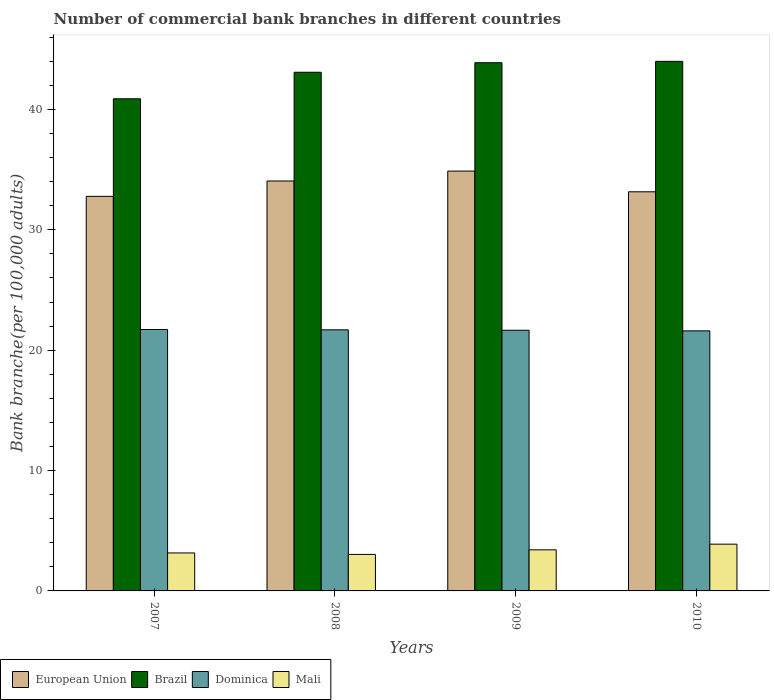How many different coloured bars are there?
Give a very brief answer. 4. How many groups of bars are there?
Give a very brief answer. 4. Are the number of bars per tick equal to the number of legend labels?
Provide a succinct answer. Yes. Are the number of bars on each tick of the X-axis equal?
Make the answer very short. Yes. How many bars are there on the 2nd tick from the right?
Make the answer very short. 4. What is the label of the 2nd group of bars from the left?
Provide a short and direct response. 2008. In how many cases, is the number of bars for a given year not equal to the number of legend labels?
Offer a very short reply. 0. What is the number of commercial bank branches in Brazil in 2008?
Your answer should be very brief. 43.09. Across all years, what is the maximum number of commercial bank branches in Brazil?
Keep it short and to the point. 43.99. Across all years, what is the minimum number of commercial bank branches in European Union?
Keep it short and to the point. 32.78. In which year was the number of commercial bank branches in Brazil minimum?
Make the answer very short. 2007. What is the total number of commercial bank branches in Dominica in the graph?
Offer a very short reply. 86.67. What is the difference between the number of commercial bank branches in Brazil in 2008 and that in 2009?
Your answer should be compact. -0.79. What is the difference between the number of commercial bank branches in Brazil in 2007 and the number of commercial bank branches in Mali in 2010?
Offer a terse response. 37. What is the average number of commercial bank branches in Mali per year?
Your response must be concise. 3.37. In the year 2008, what is the difference between the number of commercial bank branches in Dominica and number of commercial bank branches in European Union?
Offer a very short reply. -12.36. What is the ratio of the number of commercial bank branches in European Union in 2008 to that in 2010?
Give a very brief answer. 1.03. What is the difference between the highest and the second highest number of commercial bank branches in Mali?
Keep it short and to the point. 0.47. What is the difference between the highest and the lowest number of commercial bank branches in Brazil?
Provide a succinct answer. 3.11. Is the sum of the number of commercial bank branches in Brazil in 2007 and 2010 greater than the maximum number of commercial bank branches in Dominica across all years?
Provide a short and direct response. Yes. What does the 2nd bar from the left in 2007 represents?
Give a very brief answer. Brazil. What does the 4th bar from the right in 2010 represents?
Keep it short and to the point. European Union. Are all the bars in the graph horizontal?
Give a very brief answer. No. What is the difference between two consecutive major ticks on the Y-axis?
Your answer should be very brief. 10. Are the values on the major ticks of Y-axis written in scientific E-notation?
Keep it short and to the point. No. Does the graph contain any zero values?
Ensure brevity in your answer.  No. Does the graph contain grids?
Your answer should be compact. No. Where does the legend appear in the graph?
Provide a succinct answer. Bottom left. What is the title of the graph?
Keep it short and to the point. Number of commercial bank branches in different countries. Does "Belarus" appear as one of the legend labels in the graph?
Your response must be concise. No. What is the label or title of the X-axis?
Give a very brief answer. Years. What is the label or title of the Y-axis?
Offer a very short reply. Bank branche(per 100,0 adults). What is the Bank branche(per 100,000 adults) in European Union in 2007?
Your answer should be very brief. 32.78. What is the Bank branche(per 100,000 adults) in Brazil in 2007?
Your response must be concise. 40.88. What is the Bank branche(per 100,000 adults) in Dominica in 2007?
Offer a terse response. 21.72. What is the Bank branche(per 100,000 adults) of Mali in 2007?
Offer a terse response. 3.15. What is the Bank branche(per 100,000 adults) of European Union in 2008?
Provide a short and direct response. 34.05. What is the Bank branche(per 100,000 adults) in Brazil in 2008?
Your response must be concise. 43.09. What is the Bank branche(per 100,000 adults) in Dominica in 2008?
Give a very brief answer. 21.69. What is the Bank branche(per 100,000 adults) in Mali in 2008?
Make the answer very short. 3.03. What is the Bank branche(per 100,000 adults) of European Union in 2009?
Give a very brief answer. 34.88. What is the Bank branche(per 100,000 adults) in Brazil in 2009?
Make the answer very short. 43.88. What is the Bank branche(per 100,000 adults) in Dominica in 2009?
Provide a succinct answer. 21.66. What is the Bank branche(per 100,000 adults) of Mali in 2009?
Offer a terse response. 3.42. What is the Bank branche(per 100,000 adults) of European Union in 2010?
Offer a very short reply. 33.16. What is the Bank branche(per 100,000 adults) of Brazil in 2010?
Ensure brevity in your answer.  43.99. What is the Bank branche(per 100,000 adults) in Dominica in 2010?
Provide a short and direct response. 21.6. What is the Bank branche(per 100,000 adults) of Mali in 2010?
Your answer should be very brief. 3.88. Across all years, what is the maximum Bank branche(per 100,000 adults) in European Union?
Ensure brevity in your answer.  34.88. Across all years, what is the maximum Bank branche(per 100,000 adults) of Brazil?
Ensure brevity in your answer.  43.99. Across all years, what is the maximum Bank branche(per 100,000 adults) in Dominica?
Provide a short and direct response. 21.72. Across all years, what is the maximum Bank branche(per 100,000 adults) of Mali?
Your response must be concise. 3.88. Across all years, what is the minimum Bank branche(per 100,000 adults) of European Union?
Your answer should be compact. 32.78. Across all years, what is the minimum Bank branche(per 100,000 adults) of Brazil?
Make the answer very short. 40.88. Across all years, what is the minimum Bank branche(per 100,000 adults) of Dominica?
Your response must be concise. 21.6. Across all years, what is the minimum Bank branche(per 100,000 adults) of Mali?
Keep it short and to the point. 3.03. What is the total Bank branche(per 100,000 adults) of European Union in the graph?
Provide a succinct answer. 134.87. What is the total Bank branche(per 100,000 adults) in Brazil in the graph?
Your response must be concise. 171.85. What is the total Bank branche(per 100,000 adults) of Dominica in the graph?
Offer a terse response. 86.67. What is the total Bank branche(per 100,000 adults) of Mali in the graph?
Offer a very short reply. 13.49. What is the difference between the Bank branche(per 100,000 adults) in European Union in 2007 and that in 2008?
Make the answer very short. -1.28. What is the difference between the Bank branche(per 100,000 adults) of Brazil in 2007 and that in 2008?
Your answer should be very brief. -2.2. What is the difference between the Bank branche(per 100,000 adults) of Dominica in 2007 and that in 2008?
Provide a short and direct response. 0.03. What is the difference between the Bank branche(per 100,000 adults) of Mali in 2007 and that in 2008?
Provide a short and direct response. 0.12. What is the difference between the Bank branche(per 100,000 adults) in European Union in 2007 and that in 2009?
Ensure brevity in your answer.  -2.1. What is the difference between the Bank branche(per 100,000 adults) of Brazil in 2007 and that in 2009?
Keep it short and to the point. -3. What is the difference between the Bank branche(per 100,000 adults) of Dominica in 2007 and that in 2009?
Your answer should be compact. 0.06. What is the difference between the Bank branche(per 100,000 adults) in Mali in 2007 and that in 2009?
Your answer should be very brief. -0.26. What is the difference between the Bank branche(per 100,000 adults) in European Union in 2007 and that in 2010?
Give a very brief answer. -0.38. What is the difference between the Bank branche(per 100,000 adults) of Brazil in 2007 and that in 2010?
Provide a short and direct response. -3.11. What is the difference between the Bank branche(per 100,000 adults) of Dominica in 2007 and that in 2010?
Your response must be concise. 0.11. What is the difference between the Bank branche(per 100,000 adults) of Mali in 2007 and that in 2010?
Your answer should be compact. -0.73. What is the difference between the Bank branche(per 100,000 adults) in European Union in 2008 and that in 2009?
Keep it short and to the point. -0.82. What is the difference between the Bank branche(per 100,000 adults) in Brazil in 2008 and that in 2009?
Offer a very short reply. -0.79. What is the difference between the Bank branche(per 100,000 adults) in Dominica in 2008 and that in 2009?
Offer a very short reply. 0.03. What is the difference between the Bank branche(per 100,000 adults) of Mali in 2008 and that in 2009?
Keep it short and to the point. -0.38. What is the difference between the Bank branche(per 100,000 adults) in European Union in 2008 and that in 2010?
Provide a short and direct response. 0.9. What is the difference between the Bank branche(per 100,000 adults) of Brazil in 2008 and that in 2010?
Give a very brief answer. -0.91. What is the difference between the Bank branche(per 100,000 adults) in Dominica in 2008 and that in 2010?
Your answer should be very brief. 0.09. What is the difference between the Bank branche(per 100,000 adults) of Mali in 2008 and that in 2010?
Keep it short and to the point. -0.85. What is the difference between the Bank branche(per 100,000 adults) of European Union in 2009 and that in 2010?
Offer a very short reply. 1.72. What is the difference between the Bank branche(per 100,000 adults) of Brazil in 2009 and that in 2010?
Provide a short and direct response. -0.11. What is the difference between the Bank branche(per 100,000 adults) of Dominica in 2009 and that in 2010?
Provide a short and direct response. 0.05. What is the difference between the Bank branche(per 100,000 adults) in Mali in 2009 and that in 2010?
Your answer should be compact. -0.47. What is the difference between the Bank branche(per 100,000 adults) of European Union in 2007 and the Bank branche(per 100,000 adults) of Brazil in 2008?
Offer a very short reply. -10.31. What is the difference between the Bank branche(per 100,000 adults) in European Union in 2007 and the Bank branche(per 100,000 adults) in Dominica in 2008?
Your answer should be compact. 11.09. What is the difference between the Bank branche(per 100,000 adults) of European Union in 2007 and the Bank branche(per 100,000 adults) of Mali in 2008?
Your answer should be compact. 29.75. What is the difference between the Bank branche(per 100,000 adults) of Brazil in 2007 and the Bank branche(per 100,000 adults) of Dominica in 2008?
Provide a short and direct response. 19.19. What is the difference between the Bank branche(per 100,000 adults) of Brazil in 2007 and the Bank branche(per 100,000 adults) of Mali in 2008?
Give a very brief answer. 37.85. What is the difference between the Bank branche(per 100,000 adults) of Dominica in 2007 and the Bank branche(per 100,000 adults) of Mali in 2008?
Offer a terse response. 18.68. What is the difference between the Bank branche(per 100,000 adults) in European Union in 2007 and the Bank branche(per 100,000 adults) in Brazil in 2009?
Make the answer very short. -11.1. What is the difference between the Bank branche(per 100,000 adults) of European Union in 2007 and the Bank branche(per 100,000 adults) of Dominica in 2009?
Your response must be concise. 11.12. What is the difference between the Bank branche(per 100,000 adults) of European Union in 2007 and the Bank branche(per 100,000 adults) of Mali in 2009?
Your answer should be compact. 29.36. What is the difference between the Bank branche(per 100,000 adults) of Brazil in 2007 and the Bank branche(per 100,000 adults) of Dominica in 2009?
Your answer should be compact. 19.23. What is the difference between the Bank branche(per 100,000 adults) of Brazil in 2007 and the Bank branche(per 100,000 adults) of Mali in 2009?
Keep it short and to the point. 37.47. What is the difference between the Bank branche(per 100,000 adults) of Dominica in 2007 and the Bank branche(per 100,000 adults) of Mali in 2009?
Give a very brief answer. 18.3. What is the difference between the Bank branche(per 100,000 adults) in European Union in 2007 and the Bank branche(per 100,000 adults) in Brazil in 2010?
Keep it short and to the point. -11.22. What is the difference between the Bank branche(per 100,000 adults) in European Union in 2007 and the Bank branche(per 100,000 adults) in Dominica in 2010?
Offer a very short reply. 11.17. What is the difference between the Bank branche(per 100,000 adults) of European Union in 2007 and the Bank branche(per 100,000 adults) of Mali in 2010?
Keep it short and to the point. 28.89. What is the difference between the Bank branche(per 100,000 adults) of Brazil in 2007 and the Bank branche(per 100,000 adults) of Dominica in 2010?
Offer a very short reply. 19.28. What is the difference between the Bank branche(per 100,000 adults) of Brazil in 2007 and the Bank branche(per 100,000 adults) of Mali in 2010?
Keep it short and to the point. 37. What is the difference between the Bank branche(per 100,000 adults) in Dominica in 2007 and the Bank branche(per 100,000 adults) in Mali in 2010?
Ensure brevity in your answer.  17.83. What is the difference between the Bank branche(per 100,000 adults) of European Union in 2008 and the Bank branche(per 100,000 adults) of Brazil in 2009?
Provide a succinct answer. -9.83. What is the difference between the Bank branche(per 100,000 adults) of European Union in 2008 and the Bank branche(per 100,000 adults) of Dominica in 2009?
Your response must be concise. 12.4. What is the difference between the Bank branche(per 100,000 adults) of European Union in 2008 and the Bank branche(per 100,000 adults) of Mali in 2009?
Keep it short and to the point. 30.64. What is the difference between the Bank branche(per 100,000 adults) of Brazil in 2008 and the Bank branche(per 100,000 adults) of Dominica in 2009?
Provide a short and direct response. 21.43. What is the difference between the Bank branche(per 100,000 adults) of Brazil in 2008 and the Bank branche(per 100,000 adults) of Mali in 2009?
Your answer should be very brief. 39.67. What is the difference between the Bank branche(per 100,000 adults) of Dominica in 2008 and the Bank branche(per 100,000 adults) of Mali in 2009?
Give a very brief answer. 18.28. What is the difference between the Bank branche(per 100,000 adults) of European Union in 2008 and the Bank branche(per 100,000 adults) of Brazil in 2010?
Provide a short and direct response. -9.94. What is the difference between the Bank branche(per 100,000 adults) in European Union in 2008 and the Bank branche(per 100,000 adults) in Dominica in 2010?
Provide a short and direct response. 12.45. What is the difference between the Bank branche(per 100,000 adults) of European Union in 2008 and the Bank branche(per 100,000 adults) of Mali in 2010?
Make the answer very short. 30.17. What is the difference between the Bank branche(per 100,000 adults) of Brazil in 2008 and the Bank branche(per 100,000 adults) of Dominica in 2010?
Provide a short and direct response. 21.48. What is the difference between the Bank branche(per 100,000 adults) of Brazil in 2008 and the Bank branche(per 100,000 adults) of Mali in 2010?
Offer a very short reply. 39.2. What is the difference between the Bank branche(per 100,000 adults) of Dominica in 2008 and the Bank branche(per 100,000 adults) of Mali in 2010?
Offer a terse response. 17.81. What is the difference between the Bank branche(per 100,000 adults) in European Union in 2009 and the Bank branche(per 100,000 adults) in Brazil in 2010?
Your answer should be very brief. -9.12. What is the difference between the Bank branche(per 100,000 adults) of European Union in 2009 and the Bank branche(per 100,000 adults) of Dominica in 2010?
Your response must be concise. 13.27. What is the difference between the Bank branche(per 100,000 adults) of European Union in 2009 and the Bank branche(per 100,000 adults) of Mali in 2010?
Make the answer very short. 30.99. What is the difference between the Bank branche(per 100,000 adults) of Brazil in 2009 and the Bank branche(per 100,000 adults) of Dominica in 2010?
Offer a terse response. 22.28. What is the difference between the Bank branche(per 100,000 adults) of Brazil in 2009 and the Bank branche(per 100,000 adults) of Mali in 2010?
Offer a very short reply. 40. What is the difference between the Bank branche(per 100,000 adults) in Dominica in 2009 and the Bank branche(per 100,000 adults) in Mali in 2010?
Your response must be concise. 17.77. What is the average Bank branche(per 100,000 adults) of European Union per year?
Provide a succinct answer. 33.72. What is the average Bank branche(per 100,000 adults) in Brazil per year?
Offer a very short reply. 42.96. What is the average Bank branche(per 100,000 adults) in Dominica per year?
Provide a succinct answer. 21.67. What is the average Bank branche(per 100,000 adults) of Mali per year?
Ensure brevity in your answer.  3.37. In the year 2007, what is the difference between the Bank branche(per 100,000 adults) in European Union and Bank branche(per 100,000 adults) in Brazil?
Your answer should be compact. -8.11. In the year 2007, what is the difference between the Bank branche(per 100,000 adults) of European Union and Bank branche(per 100,000 adults) of Dominica?
Provide a succinct answer. 11.06. In the year 2007, what is the difference between the Bank branche(per 100,000 adults) of European Union and Bank branche(per 100,000 adults) of Mali?
Your answer should be compact. 29.62. In the year 2007, what is the difference between the Bank branche(per 100,000 adults) of Brazil and Bank branche(per 100,000 adults) of Dominica?
Keep it short and to the point. 19.17. In the year 2007, what is the difference between the Bank branche(per 100,000 adults) in Brazil and Bank branche(per 100,000 adults) in Mali?
Offer a very short reply. 37.73. In the year 2007, what is the difference between the Bank branche(per 100,000 adults) in Dominica and Bank branche(per 100,000 adults) in Mali?
Your response must be concise. 18.56. In the year 2008, what is the difference between the Bank branche(per 100,000 adults) of European Union and Bank branche(per 100,000 adults) of Brazil?
Provide a short and direct response. -9.03. In the year 2008, what is the difference between the Bank branche(per 100,000 adults) in European Union and Bank branche(per 100,000 adults) in Dominica?
Offer a very short reply. 12.36. In the year 2008, what is the difference between the Bank branche(per 100,000 adults) of European Union and Bank branche(per 100,000 adults) of Mali?
Your response must be concise. 31.02. In the year 2008, what is the difference between the Bank branche(per 100,000 adults) in Brazil and Bank branche(per 100,000 adults) in Dominica?
Ensure brevity in your answer.  21.4. In the year 2008, what is the difference between the Bank branche(per 100,000 adults) in Brazil and Bank branche(per 100,000 adults) in Mali?
Provide a succinct answer. 40.06. In the year 2008, what is the difference between the Bank branche(per 100,000 adults) in Dominica and Bank branche(per 100,000 adults) in Mali?
Make the answer very short. 18.66. In the year 2009, what is the difference between the Bank branche(per 100,000 adults) of European Union and Bank branche(per 100,000 adults) of Brazil?
Your response must be concise. -9. In the year 2009, what is the difference between the Bank branche(per 100,000 adults) of European Union and Bank branche(per 100,000 adults) of Dominica?
Keep it short and to the point. 13.22. In the year 2009, what is the difference between the Bank branche(per 100,000 adults) in European Union and Bank branche(per 100,000 adults) in Mali?
Your answer should be compact. 31.46. In the year 2009, what is the difference between the Bank branche(per 100,000 adults) of Brazil and Bank branche(per 100,000 adults) of Dominica?
Provide a short and direct response. 22.23. In the year 2009, what is the difference between the Bank branche(per 100,000 adults) in Brazil and Bank branche(per 100,000 adults) in Mali?
Keep it short and to the point. 40.47. In the year 2009, what is the difference between the Bank branche(per 100,000 adults) in Dominica and Bank branche(per 100,000 adults) in Mali?
Offer a very short reply. 18.24. In the year 2010, what is the difference between the Bank branche(per 100,000 adults) of European Union and Bank branche(per 100,000 adults) of Brazil?
Your response must be concise. -10.84. In the year 2010, what is the difference between the Bank branche(per 100,000 adults) of European Union and Bank branche(per 100,000 adults) of Dominica?
Provide a succinct answer. 11.55. In the year 2010, what is the difference between the Bank branche(per 100,000 adults) in European Union and Bank branche(per 100,000 adults) in Mali?
Your response must be concise. 29.27. In the year 2010, what is the difference between the Bank branche(per 100,000 adults) in Brazil and Bank branche(per 100,000 adults) in Dominica?
Keep it short and to the point. 22.39. In the year 2010, what is the difference between the Bank branche(per 100,000 adults) of Brazil and Bank branche(per 100,000 adults) of Mali?
Your response must be concise. 40.11. In the year 2010, what is the difference between the Bank branche(per 100,000 adults) of Dominica and Bank branche(per 100,000 adults) of Mali?
Make the answer very short. 17.72. What is the ratio of the Bank branche(per 100,000 adults) of European Union in 2007 to that in 2008?
Your response must be concise. 0.96. What is the ratio of the Bank branche(per 100,000 adults) in Brazil in 2007 to that in 2008?
Provide a short and direct response. 0.95. What is the ratio of the Bank branche(per 100,000 adults) in Dominica in 2007 to that in 2008?
Offer a very short reply. 1. What is the ratio of the Bank branche(per 100,000 adults) in Mali in 2007 to that in 2008?
Make the answer very short. 1.04. What is the ratio of the Bank branche(per 100,000 adults) in European Union in 2007 to that in 2009?
Offer a very short reply. 0.94. What is the ratio of the Bank branche(per 100,000 adults) in Brazil in 2007 to that in 2009?
Your answer should be very brief. 0.93. What is the ratio of the Bank branche(per 100,000 adults) of Mali in 2007 to that in 2009?
Offer a terse response. 0.92. What is the ratio of the Bank branche(per 100,000 adults) of European Union in 2007 to that in 2010?
Your answer should be compact. 0.99. What is the ratio of the Bank branche(per 100,000 adults) in Brazil in 2007 to that in 2010?
Your answer should be very brief. 0.93. What is the ratio of the Bank branche(per 100,000 adults) of Mali in 2007 to that in 2010?
Ensure brevity in your answer.  0.81. What is the ratio of the Bank branche(per 100,000 adults) of European Union in 2008 to that in 2009?
Ensure brevity in your answer.  0.98. What is the ratio of the Bank branche(per 100,000 adults) of Brazil in 2008 to that in 2009?
Offer a terse response. 0.98. What is the ratio of the Bank branche(per 100,000 adults) of Dominica in 2008 to that in 2009?
Your response must be concise. 1. What is the ratio of the Bank branche(per 100,000 adults) of Mali in 2008 to that in 2009?
Give a very brief answer. 0.89. What is the ratio of the Bank branche(per 100,000 adults) in European Union in 2008 to that in 2010?
Make the answer very short. 1.03. What is the ratio of the Bank branche(per 100,000 adults) of Brazil in 2008 to that in 2010?
Keep it short and to the point. 0.98. What is the ratio of the Bank branche(per 100,000 adults) of Dominica in 2008 to that in 2010?
Provide a succinct answer. 1. What is the ratio of the Bank branche(per 100,000 adults) in Mali in 2008 to that in 2010?
Make the answer very short. 0.78. What is the ratio of the Bank branche(per 100,000 adults) of European Union in 2009 to that in 2010?
Your answer should be very brief. 1.05. What is the ratio of the Bank branche(per 100,000 adults) of Mali in 2009 to that in 2010?
Give a very brief answer. 0.88. What is the difference between the highest and the second highest Bank branche(per 100,000 adults) of European Union?
Your response must be concise. 0.82. What is the difference between the highest and the second highest Bank branche(per 100,000 adults) of Brazil?
Keep it short and to the point. 0.11. What is the difference between the highest and the second highest Bank branche(per 100,000 adults) of Dominica?
Your answer should be very brief. 0.03. What is the difference between the highest and the second highest Bank branche(per 100,000 adults) of Mali?
Your response must be concise. 0.47. What is the difference between the highest and the lowest Bank branche(per 100,000 adults) in European Union?
Make the answer very short. 2.1. What is the difference between the highest and the lowest Bank branche(per 100,000 adults) of Brazil?
Your answer should be compact. 3.11. What is the difference between the highest and the lowest Bank branche(per 100,000 adults) in Dominica?
Your answer should be very brief. 0.11. What is the difference between the highest and the lowest Bank branche(per 100,000 adults) in Mali?
Provide a short and direct response. 0.85. 